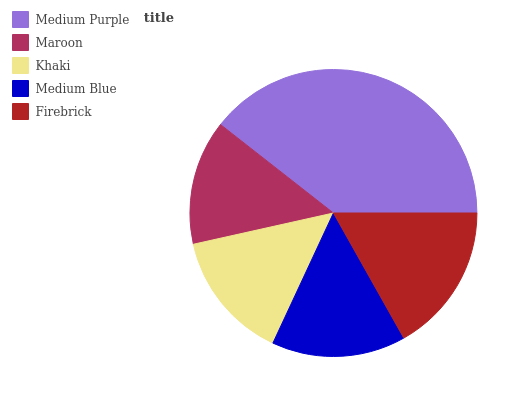Is Maroon the minimum?
Answer yes or no. Yes. Is Medium Purple the maximum?
Answer yes or no. Yes. Is Khaki the minimum?
Answer yes or no. No. Is Khaki the maximum?
Answer yes or no. No. Is Khaki greater than Maroon?
Answer yes or no. Yes. Is Maroon less than Khaki?
Answer yes or no. Yes. Is Maroon greater than Khaki?
Answer yes or no. No. Is Khaki less than Maroon?
Answer yes or no. No. Is Medium Blue the high median?
Answer yes or no. Yes. Is Medium Blue the low median?
Answer yes or no. Yes. Is Medium Purple the high median?
Answer yes or no. No. Is Khaki the low median?
Answer yes or no. No. 